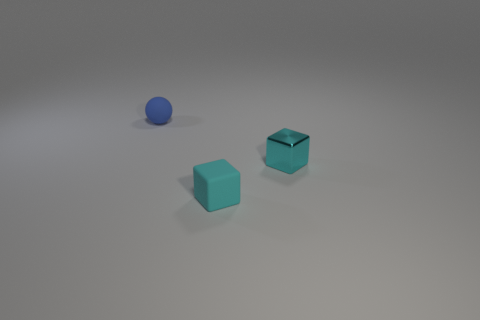Is there any reflective surface present in the image? Yes, the surface on which the objects are placed appears to be slightly reflective. It subtly mirrors the shapes of the objects, adding another layer of visual interest and enhancing the overall minimalistic aesthetic of the setup. 